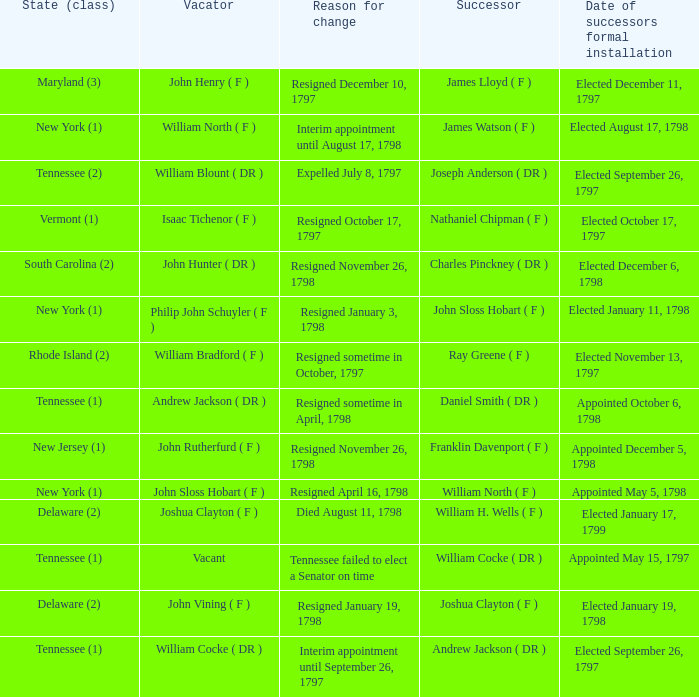What are all the states (class) when the reason for change was resigned November 26, 1798 and the vacator was John Hunter ( DR )? South Carolina (2). 